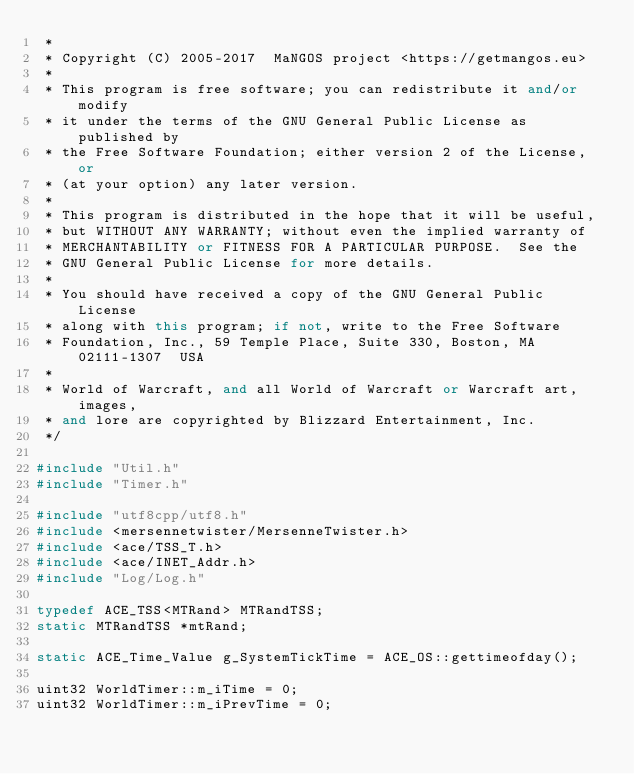Convert code to text. <code><loc_0><loc_0><loc_500><loc_500><_C++_> *
 * Copyright (C) 2005-2017  MaNGOS project <https://getmangos.eu>
 *
 * This program is free software; you can redistribute it and/or modify
 * it under the terms of the GNU General Public License as published by
 * the Free Software Foundation; either version 2 of the License, or
 * (at your option) any later version.
 *
 * This program is distributed in the hope that it will be useful,
 * but WITHOUT ANY WARRANTY; without even the implied warranty of
 * MERCHANTABILITY or FITNESS FOR A PARTICULAR PURPOSE.  See the
 * GNU General Public License for more details.
 *
 * You should have received a copy of the GNU General Public License
 * along with this program; if not, write to the Free Software
 * Foundation, Inc., 59 Temple Place, Suite 330, Boston, MA  02111-1307  USA
 *
 * World of Warcraft, and all World of Warcraft or Warcraft art, images,
 * and lore are copyrighted by Blizzard Entertainment, Inc.
 */

#include "Util.h"
#include "Timer.h"

#include "utf8cpp/utf8.h"
#include <mersennetwister/MersenneTwister.h>
#include <ace/TSS_T.h>
#include <ace/INET_Addr.h>
#include "Log/Log.h"

typedef ACE_TSS<MTRand> MTRandTSS;
static MTRandTSS *mtRand;

static ACE_Time_Value g_SystemTickTime = ACE_OS::gettimeofday();

uint32 WorldTimer::m_iTime = 0;
uint32 WorldTimer::m_iPrevTime = 0;
</code> 